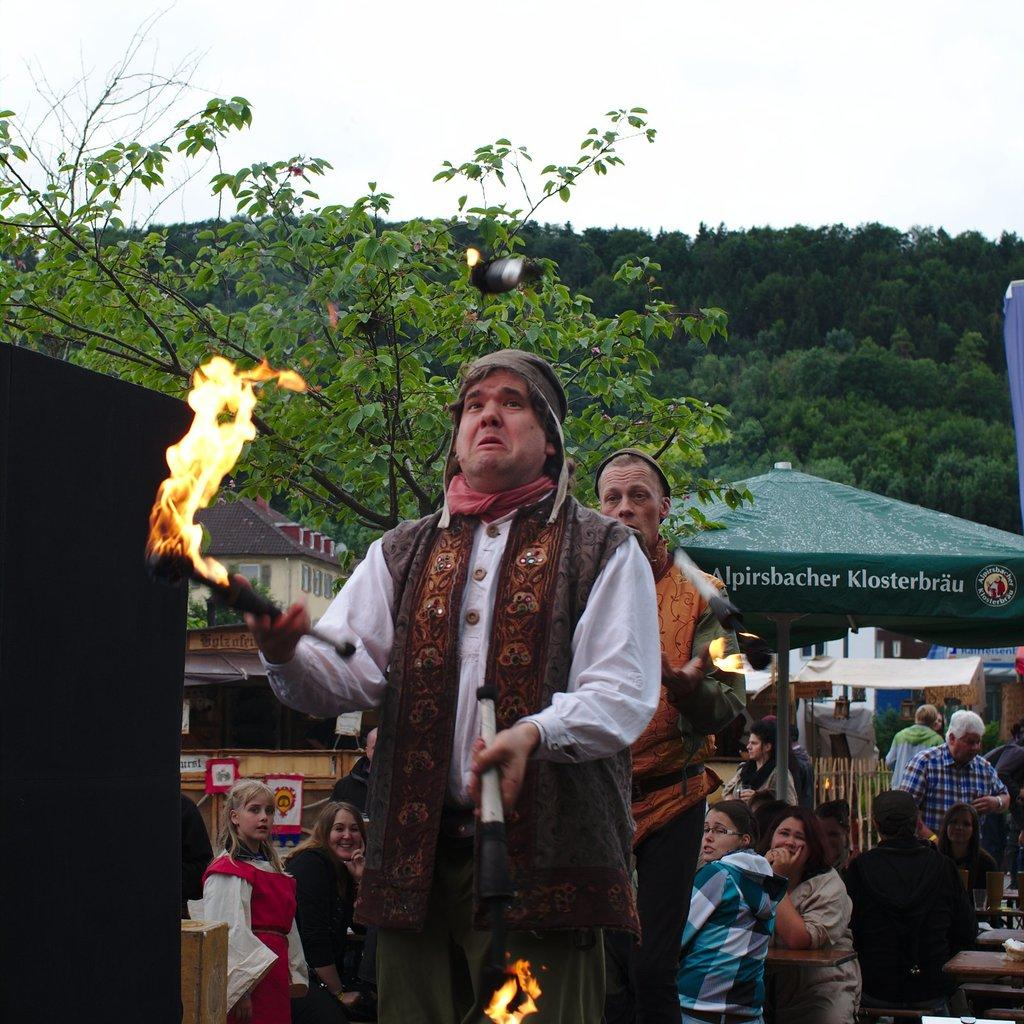What type of temporary shelters can be seen in the image? There are tents in the image. What else can be found in the image besides tents? There are stalls in the image. What is the person in the image doing? The person is holding fire in the image. What type of vegetation is visible at the top of the image? There are trees at the top of the image. What is visible in the background of the image? The sky is visible at the top of the image. What type of unit is being transported in the image? There is no unit being transported in the image. What is the afterthought of the person holding fire in the image? There is no indication of an afterthought in the image; the person is simply holding fire. 